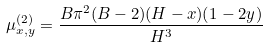Convert formula to latex. <formula><loc_0><loc_0><loc_500><loc_500>\mu _ { x , y } ^ { ( 2 ) } = \frac { B \pi ^ { 2 } ( B - 2 ) ( H - x ) ( 1 - 2 y ) } { H ^ { 3 } } \,</formula> 